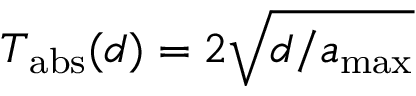<formula> <loc_0><loc_0><loc_500><loc_500>T _ { a b s } ( d ) = 2 \sqrt { d / a _ { \max } }</formula> 